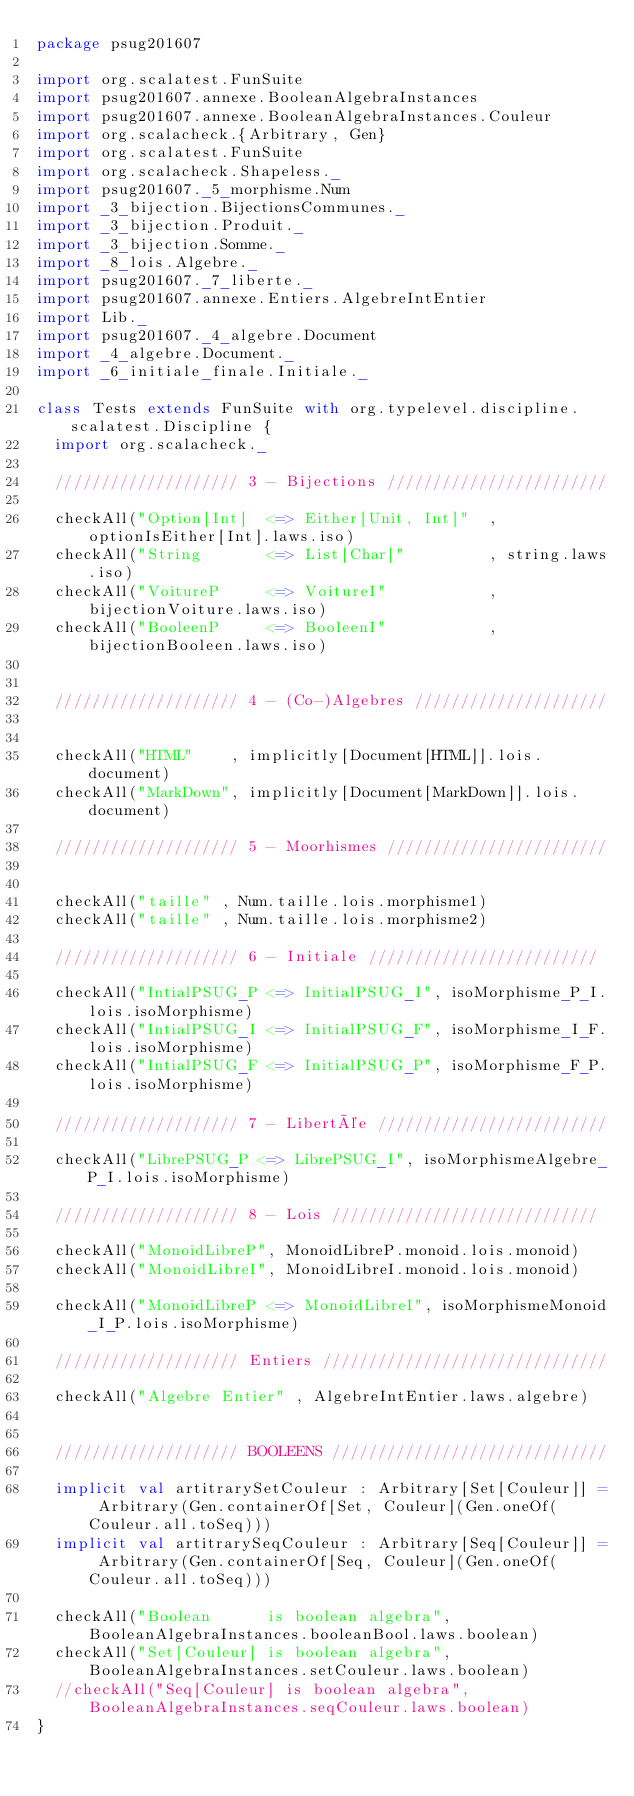Convert code to text. <code><loc_0><loc_0><loc_500><loc_500><_Scala_>package psug201607

import org.scalatest.FunSuite
import psug201607.annexe.BooleanAlgebraInstances
import psug201607.annexe.BooleanAlgebraInstances.Couleur
import org.scalacheck.{Arbitrary, Gen}
import org.scalatest.FunSuite
import org.scalacheck.Shapeless._
import psug201607._5_morphisme.Num
import _3_bijection.BijectionsCommunes._
import _3_bijection.Produit._
import _3_bijection.Somme._
import _8_lois.Algebre._
import psug201607._7_liberte._
import psug201607.annexe.Entiers.AlgebreIntEntier
import Lib._
import psug201607._4_algebre.Document
import _4_algebre.Document._
import _6_initiale_finale.Initiale._

class Tests extends FunSuite with org.typelevel.discipline.scalatest.Discipline {
  import org.scalacheck._

  //////////////////// 3 - Bijections ////////////////////////

  checkAll("Option[Int]  <=> Either[Unit, Int]"  , optionIsEither[Int].laws.iso)
  checkAll("String       <=> List[Char]"         , string.laws.iso)
  checkAll("VoitureP     <=> VoitureI"           , bijectionVoiture.laws.iso)
  checkAll("BooleenP     <=> BooleenI"           , bijectionBooleen.laws.iso)


  //////////////////// 4 - (Co-)Algebres /////////////////////


  checkAll("HTML"    , implicitly[Document[HTML]].lois.document)
  checkAll("MarkDown", implicitly[Document[MarkDown]].lois.document)

  //////////////////// 5 - Moorhismes ////////////////////////


  checkAll("taille" , Num.taille.lois.morphisme1)
  checkAll("taille" , Num.taille.lois.morphisme2)

  //////////////////// 6 - Initiale /////////////////////////

  checkAll("IntialPSUG_P <=> InitialPSUG_I", isoMorphisme_P_I.lois.isoMorphisme)
  checkAll("IntialPSUG_I <=> InitialPSUG_F", isoMorphisme_I_F.lois.isoMorphisme)
  checkAll("IntialPSUG_F <=> InitialPSUG_P", isoMorphisme_F_P.lois.isoMorphisme)

  //////////////////// 7 - Libertée /////////////////////////

  checkAll("LibrePSUG_P <=> LibrePSUG_I", isoMorphismeAlgebre_P_I.lois.isoMorphisme)

  //////////////////// 8 - Lois /////////////////////////////

  checkAll("MonoidLibreP", MonoidLibreP.monoid.lois.monoid)
  checkAll("MonoidLibreI", MonoidLibreI.monoid.lois.monoid)

  checkAll("MonoidLibreP <=> MonoidLibreI", isoMorphismeMonoid_I_P.lois.isoMorphisme)

  //////////////////// Entiers ///////////////////////////////

  checkAll("Algebre Entier" , AlgebreIntEntier.laws.algebre)


  //////////////////// BOOLEENS //////////////////////////////

  implicit val artitrarySetCouleur : Arbitrary[Set[Couleur]] = Arbitrary(Gen.containerOf[Set, Couleur](Gen.oneOf(Couleur.all.toSeq)))
  implicit val artitrarySeqCouleur : Arbitrary[Seq[Couleur]] = Arbitrary(Gen.containerOf[Seq, Couleur](Gen.oneOf(Couleur.all.toSeq)))

  checkAll("Boolean      is boolean algebra", BooleanAlgebraInstances.booleanBool.laws.boolean)
  checkAll("Set[Couleur] is boolean algebra", BooleanAlgebraInstances.setCouleur.laws.boolean)
  //checkAll("Seq[Couleur] is boolean algebra", BooleanAlgebraInstances.seqCouleur.laws.boolean)
}
</code> 